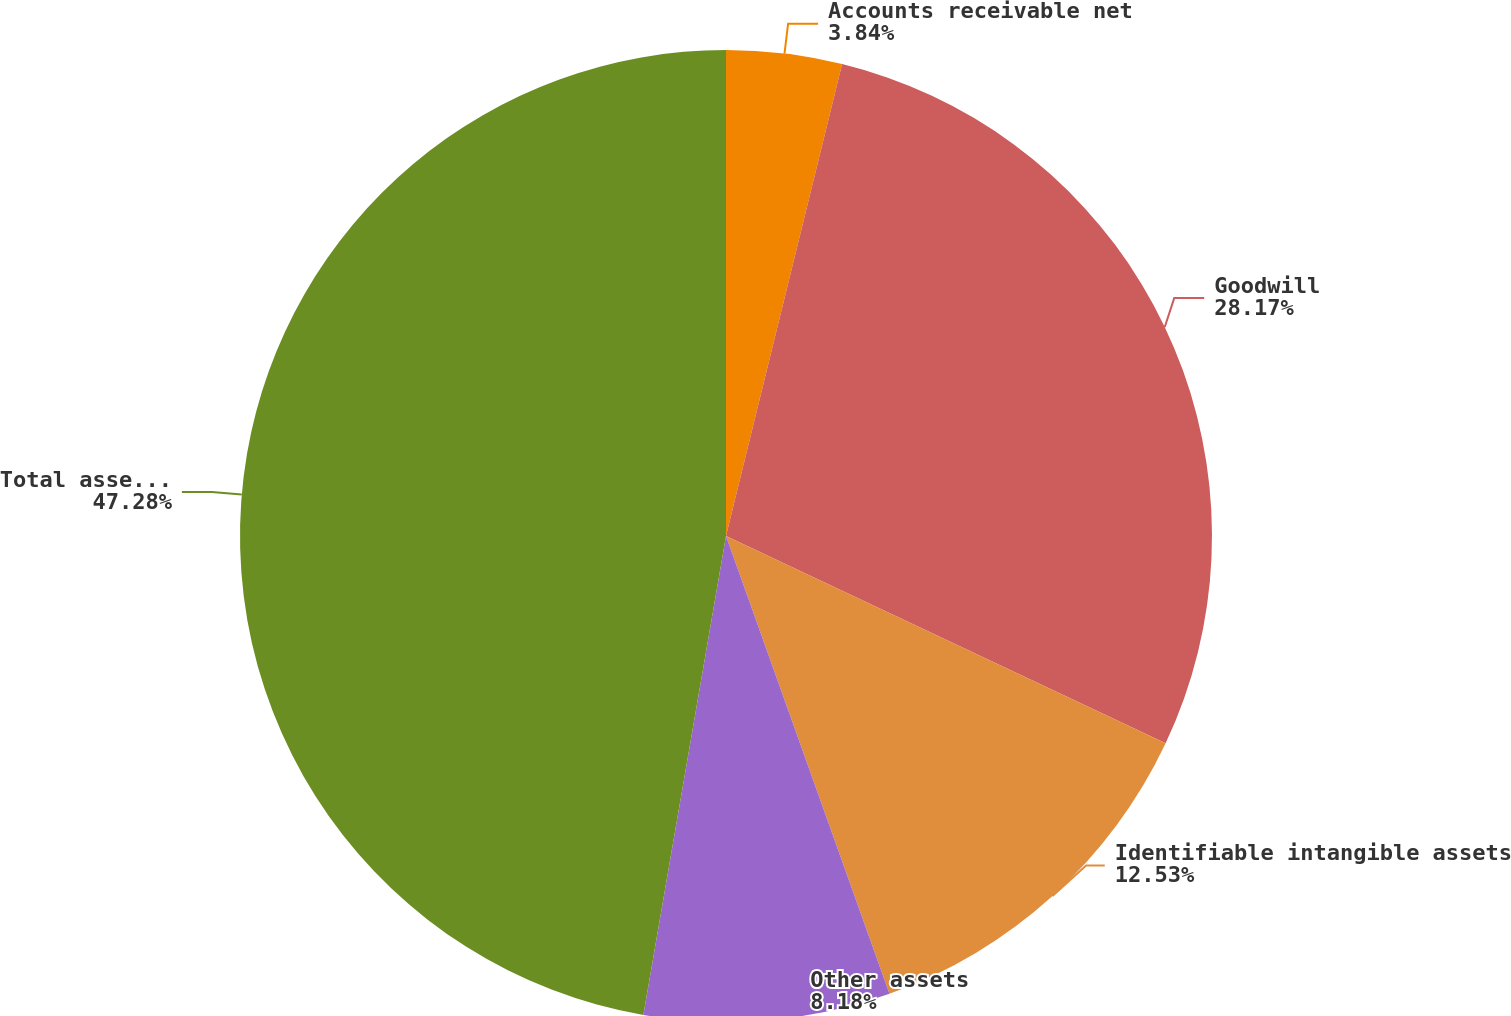Convert chart. <chart><loc_0><loc_0><loc_500><loc_500><pie_chart><fcel>Accounts receivable net<fcel>Goodwill<fcel>Identifiable intangible assets<fcel>Other assets<fcel>Total assets acquired<nl><fcel>3.84%<fcel>28.17%<fcel>12.53%<fcel>8.18%<fcel>47.28%<nl></chart> 